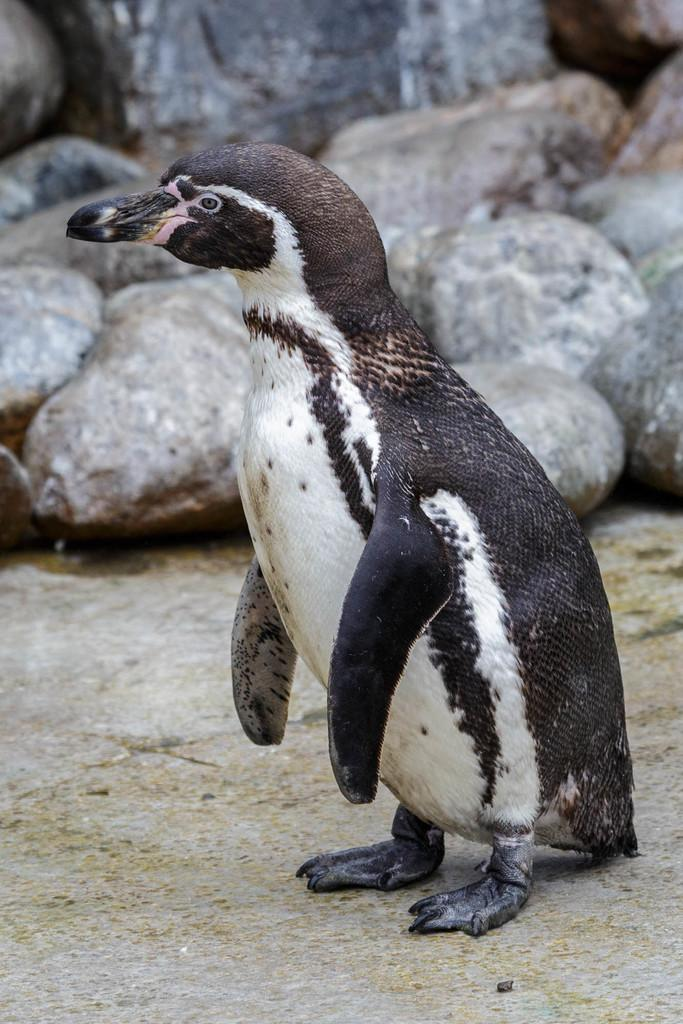What animal is present in the image? There is a penguin in the image. Where is the penguin located in the image? The penguin is on the ground. What type of natural elements can be seen in the background of the image? There are rocks visible in the background of the image. How many boys are holding a pail in the image? There are no boys or pails present in the image. What type of line can be seen connecting the penguin to the rocks in the image? There is no line connecting the penguin to the rocks in the image. 